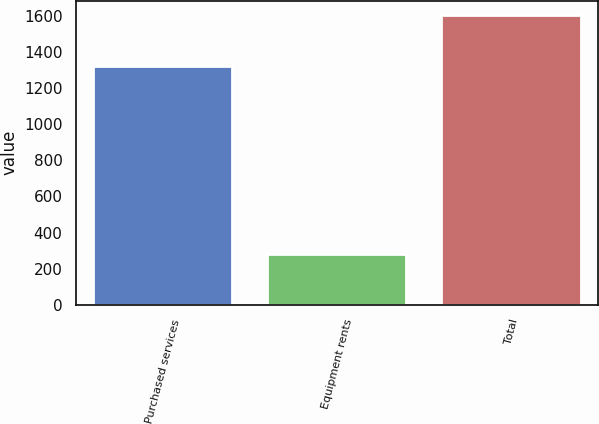Convert chart. <chart><loc_0><loc_0><loc_500><loc_500><bar_chart><fcel>Purchased services<fcel>Equipment rents<fcel>Total<nl><fcel>1321<fcel>283<fcel>1604<nl></chart> 